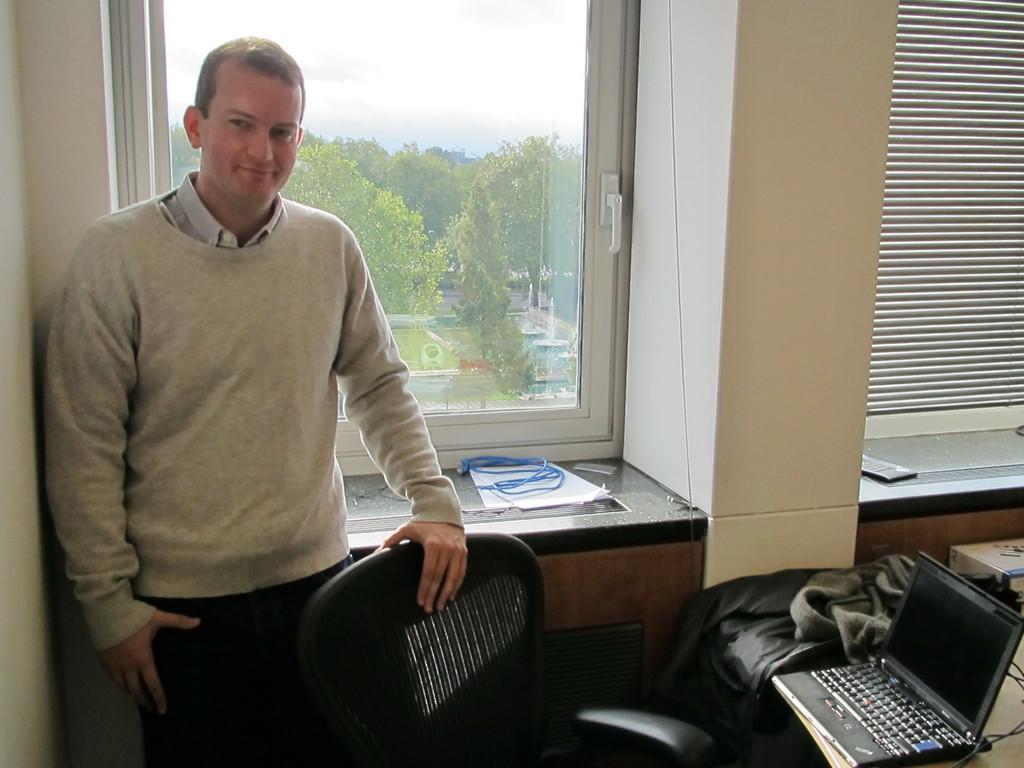Could you give a brief overview of what you see in this image? It is a room inside an office there is a man standing and posing for the photo beside him there is a black chair,to the right side of the chair there is a table and on the table there is a laptop and a jacket beside it,in the background there is a window and a wall outside that there are some trees,garden,vehicles and sky. 